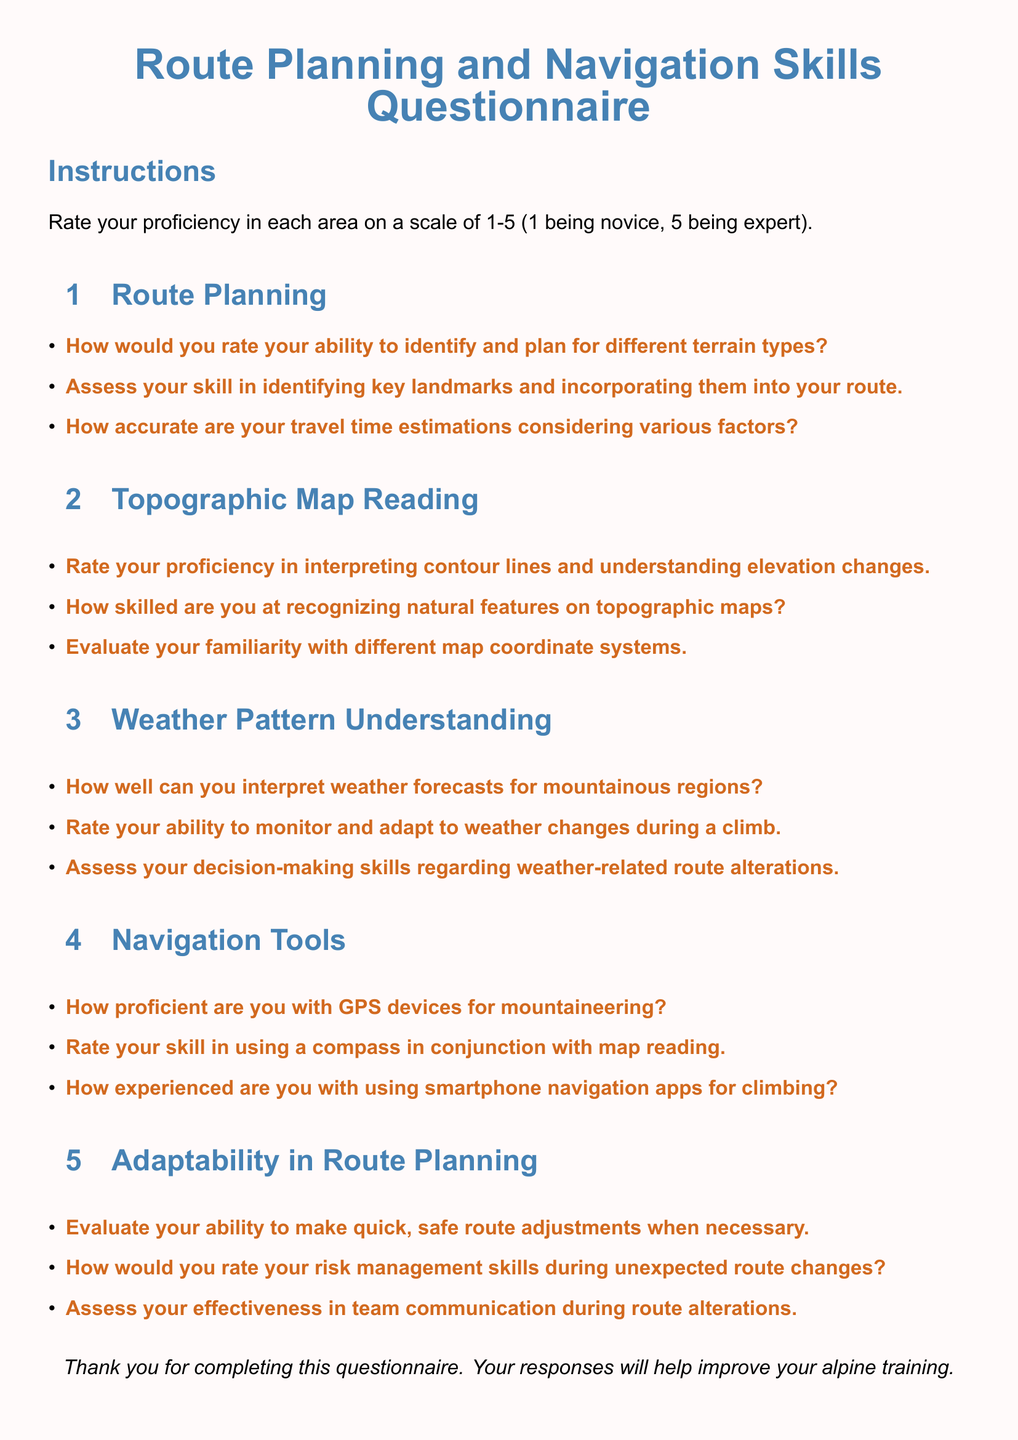What is the title of the document? The title is prominently displayed at the top center of the document in a large font, indicating its purpose.
Answer: Route Planning and Navigation Skills Questionnaire How many sections are in the questionnaire? The document includes four distinct sections, each focusing on a different aspect of route planning and navigation.
Answer: Four What is the rating scale used in the questionnaire? The document specifies a rating scale used for proficiency assessment, which indicates the range of possible ratings.
Answer: 1-5 In which section would you find questions about weather-related skills? The section headers indicate the focus areas of the questions, allowing identification of the relevant section for weather skills.
Answer: Weather Pattern Understanding How is the proficiency in GPS devices rated? The proficiency in GPS devices is specifically evaluated under the Navigation Tools section, indicating its importance for mountaineering.
Answer: GPS devices What color is used for the section titles? The document uses a specific color coding to enhance visual clarity and organization of the sections.
Answer: Mountain blue What is the focus of the "Adaptability in Route Planning" section? The section title indicates that it assesses the ability to adjust routes and manage risks during climbs.
Answer: Adaptability in Route Planning How are the questions presented in the document? The questions are laid out in a way that allows for clear responses, following a consistent format.
Answer: Itemized list How are the instructions themed in the document? The instructions are prominently formatted to guide the reader on how to respond to the questionnaire effectively.
Answer: Clear and concise 